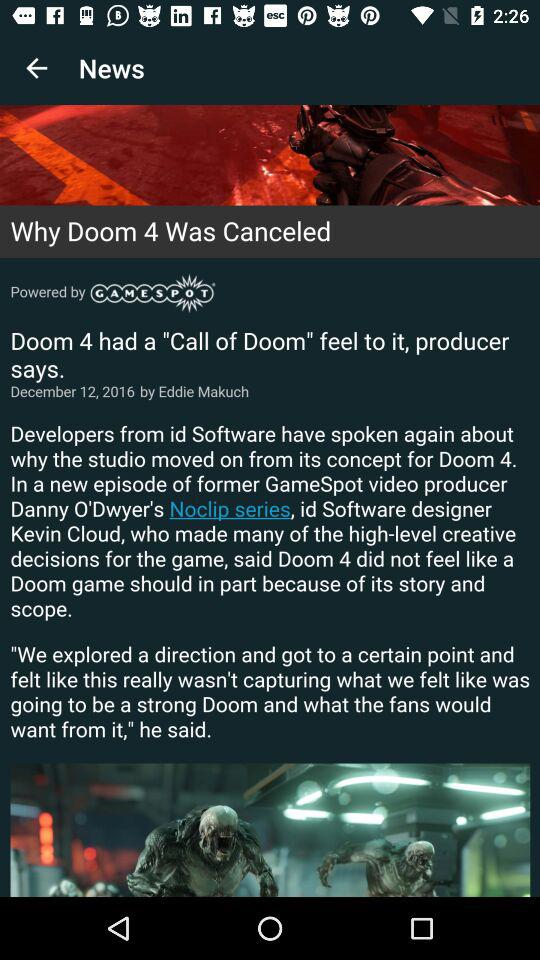On what date was the news published? The news was published on the date of December 12, 2016. 